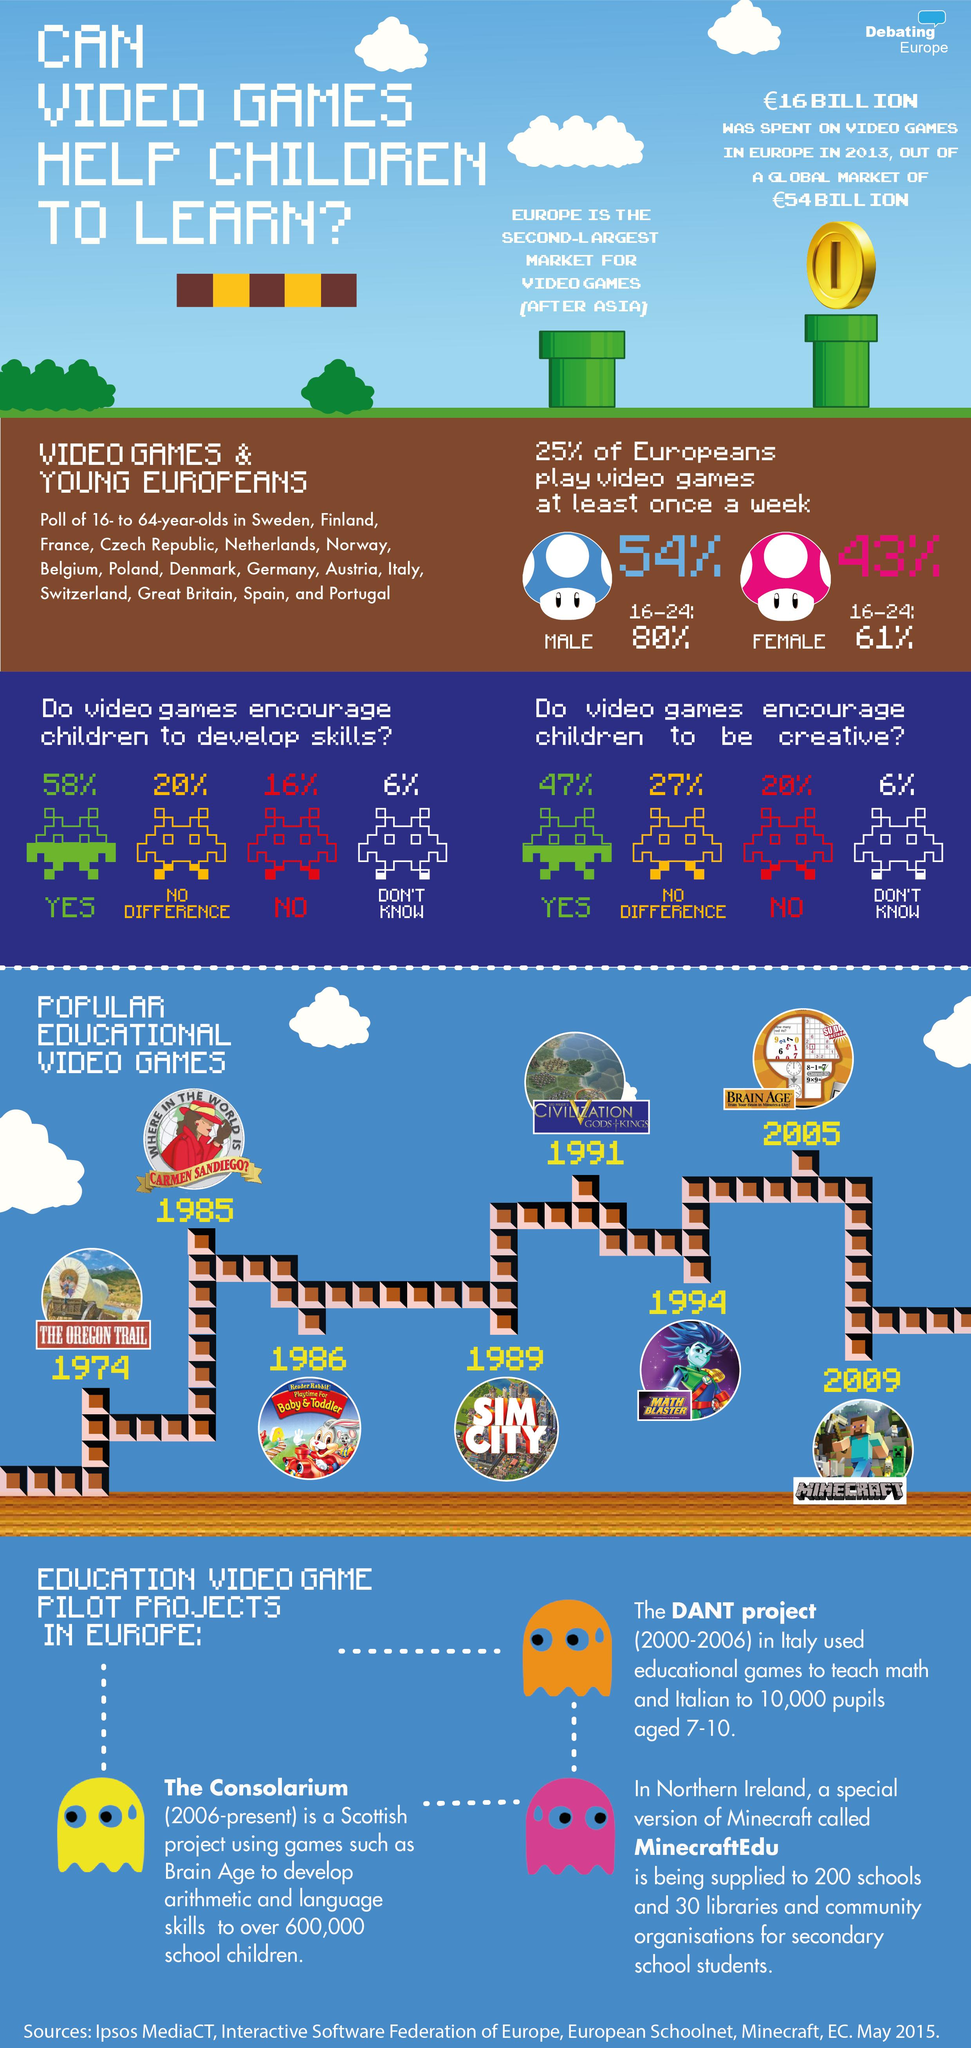Mention a couple of crucial points in this snapshot. According to a survey, a significant 20% of people believe that video games do not encourage creative skills. Out of the European individuals who engage in video game play, 43% are female. The global spending on video games in 2013, after excluding the share of Europe, was approximately 38 billion euros. Math Blaster was introduced approximately 5 years after the release of SimCity. According to recent data, Asia is the largest market for video games, attracting a significant portion of the global gaming industry's revenue. 